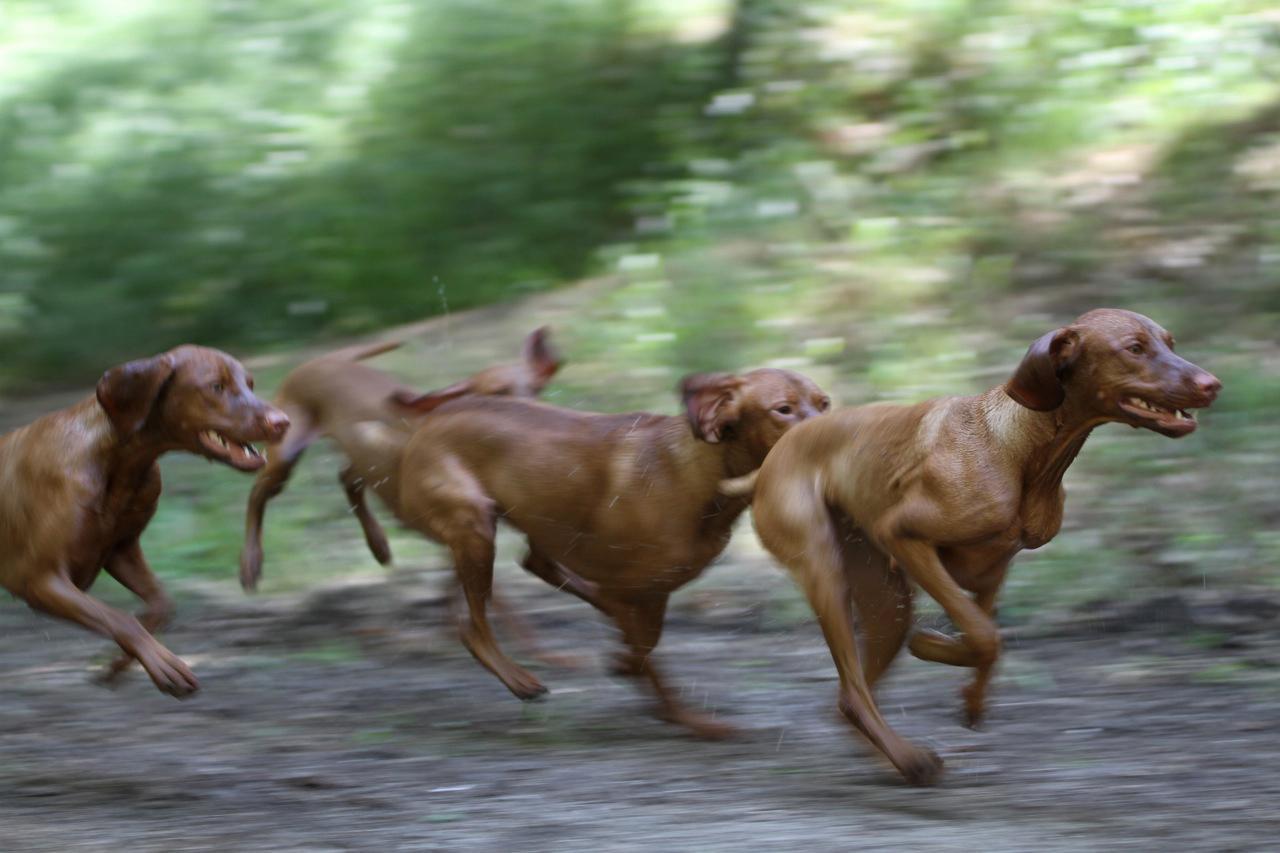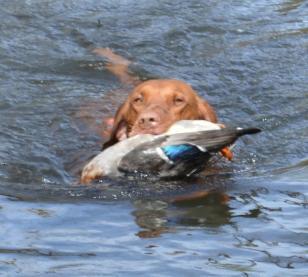The first image is the image on the left, the second image is the image on the right. Evaluate the accuracy of this statement regarding the images: "There are exactly two dogs.". Is it true? Answer yes or no. No. The first image is the image on the left, the second image is the image on the right. Assess this claim about the two images: "No more than two dogs are visible.". Correct or not? Answer yes or no. No. 